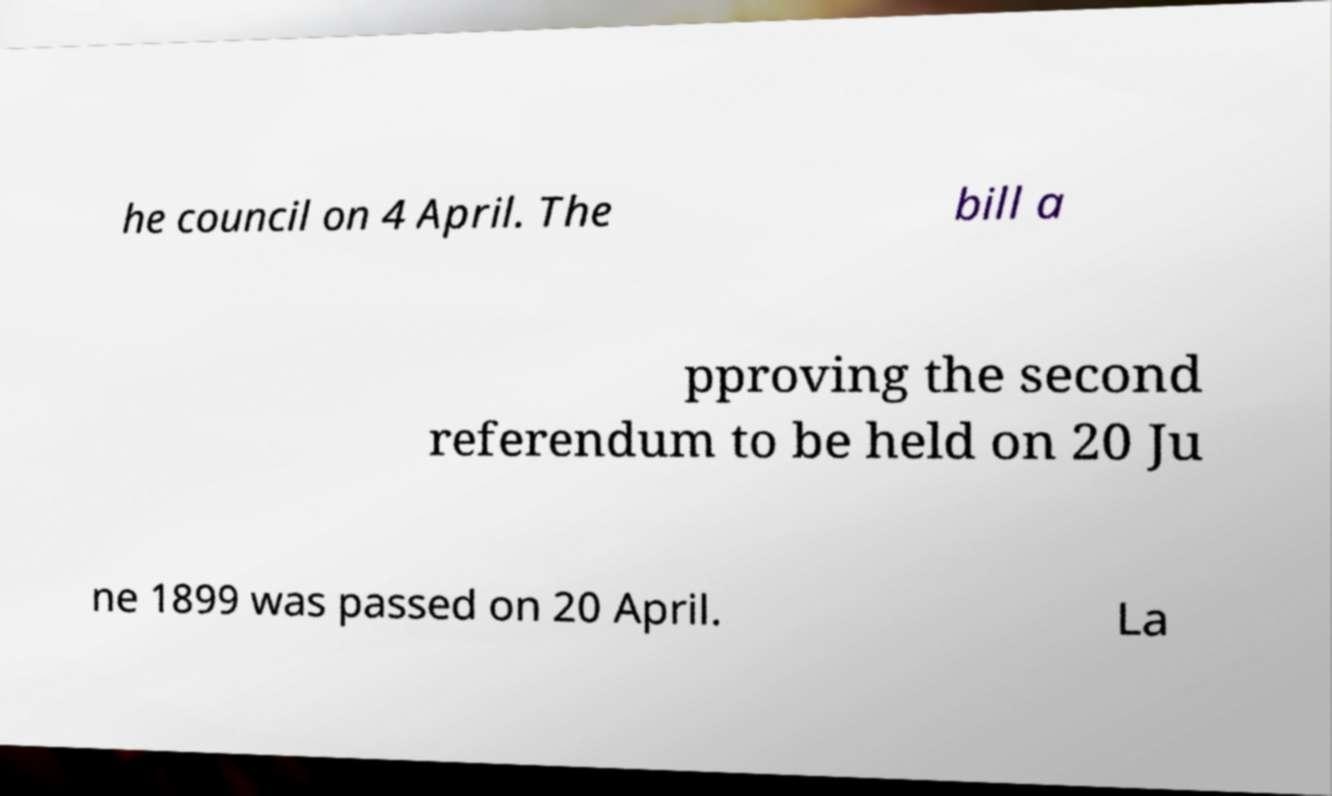I need the written content from this picture converted into text. Can you do that? he council on 4 April. The bill a pproving the second referendum to be held on 20 Ju ne 1899 was passed on 20 April. La 